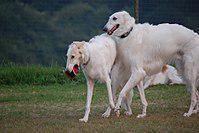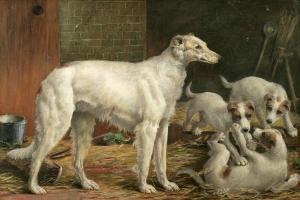The first image is the image on the left, the second image is the image on the right. For the images shown, is this caption "Two hounds with left-turned faces are in the foreground of the left image, and the right image includes at least three hounds." true? Answer yes or no. Yes. The first image is the image on the left, the second image is the image on the right. Examine the images to the left and right. Is the description "In one image there are two white dogs and in the other image there are three dogs." accurate? Answer yes or no. No. 